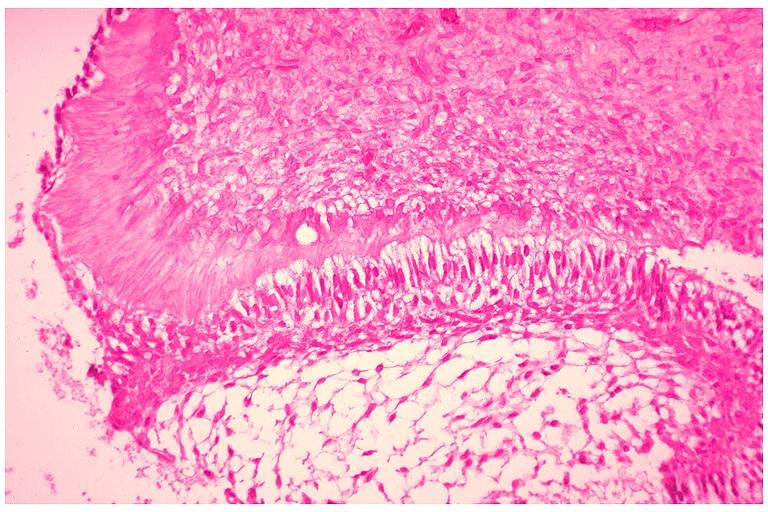s metastatic carcinoma prostate present?
Answer the question using a single word or phrase. No 